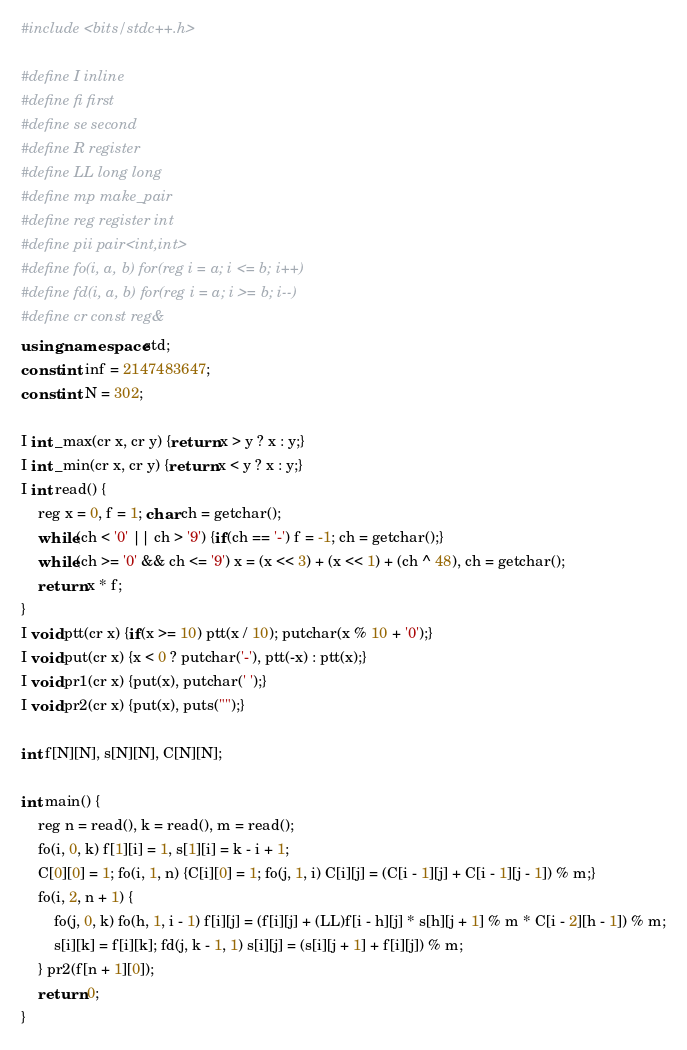<code> <loc_0><loc_0><loc_500><loc_500><_C++_>#include <bits/stdc++.h>

#define I inline
#define fi first
#define se second
#define R register
#define LL long long
#define mp make_pair
#define reg register int
#define pii pair<int,int>
#define fo(i, a, b) for(reg i = a; i <= b; i++)
#define fd(i, a, b) for(reg i = a; i >= b; i--)
#define cr const reg&
using namespace std;
const int inf = 2147483647;
const int N = 302;

I int _max(cr x, cr y) {return x > y ? x : y;}
I int _min(cr x, cr y) {return x < y ? x : y;}
I int read() {
	reg x = 0, f = 1; char ch = getchar();
	while(ch < '0' || ch > '9') {if(ch == '-') f = -1; ch = getchar();}
	while(ch >= '0' && ch <= '9') x = (x << 3) + (x << 1) + (ch ^ 48), ch = getchar();
	return x * f;
}
I void ptt(cr x) {if(x >= 10) ptt(x / 10); putchar(x % 10 + '0');}
I void put(cr x) {x < 0 ? putchar('-'), ptt(-x) : ptt(x);}
I void pr1(cr x) {put(x), putchar(' ');}
I void pr2(cr x) {put(x), puts("");}

int f[N][N], s[N][N], C[N][N];

int main() {
	reg n = read(), k = read(), m = read();
	fo(i, 0, k) f[1][i] = 1, s[1][i] = k - i + 1;
	C[0][0] = 1; fo(i, 1, n) {C[i][0] = 1; fo(j, 1, i) C[i][j] = (C[i - 1][j] + C[i - 1][j - 1]) % m;}
	fo(i, 2, n + 1) {
		fo(j, 0, k) fo(h, 1, i - 1) f[i][j] = (f[i][j] + (LL)f[i - h][j] * s[h][j + 1] % m * C[i - 2][h - 1]) % m;
		s[i][k] = f[i][k]; fd(j, k - 1, 1) s[i][j] = (s[i][j + 1] + f[i][j]) % m;
	} pr2(f[n + 1][0]);
	return 0;
}

</code> 